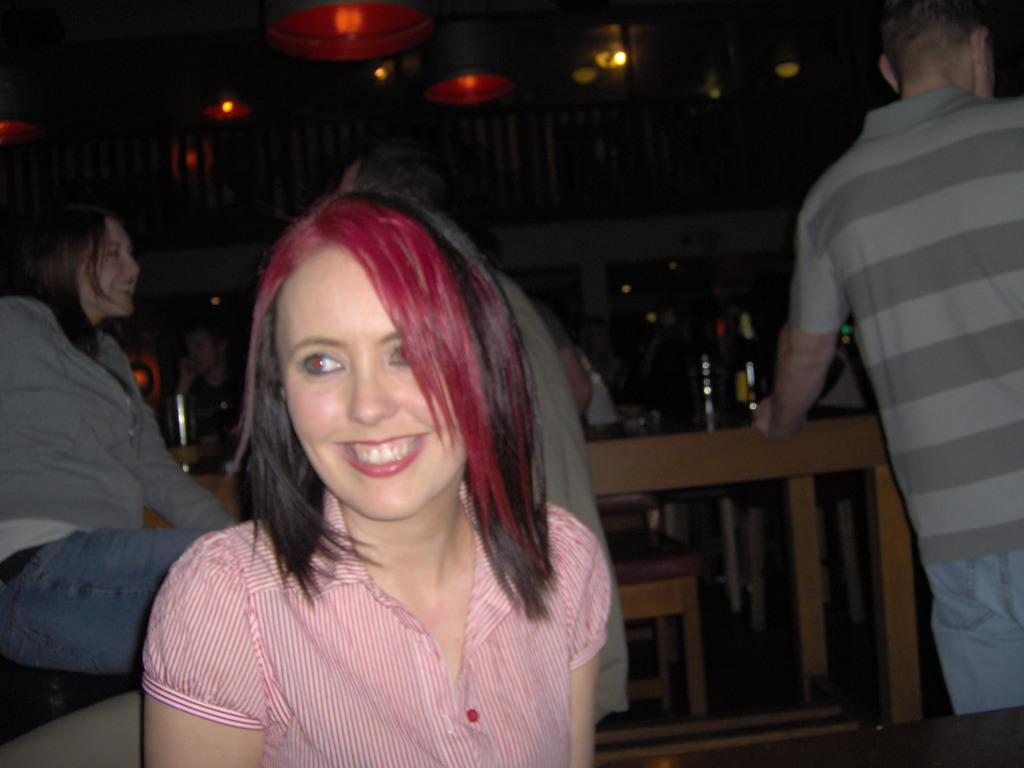Who is the main subject in the image? There is a woman in the image. What expression does the woman have? The woman is smiling. Can you describe the background of the image? There are people, bottles on a table, and other objects visible in the background of the image. What is visible at the top of the image? There are lights visible at the top of the image. What type of reaction does the father have to the cracker in the image? There is no father or cracker present in the image, so it is not possible to answer that question about their reaction. 